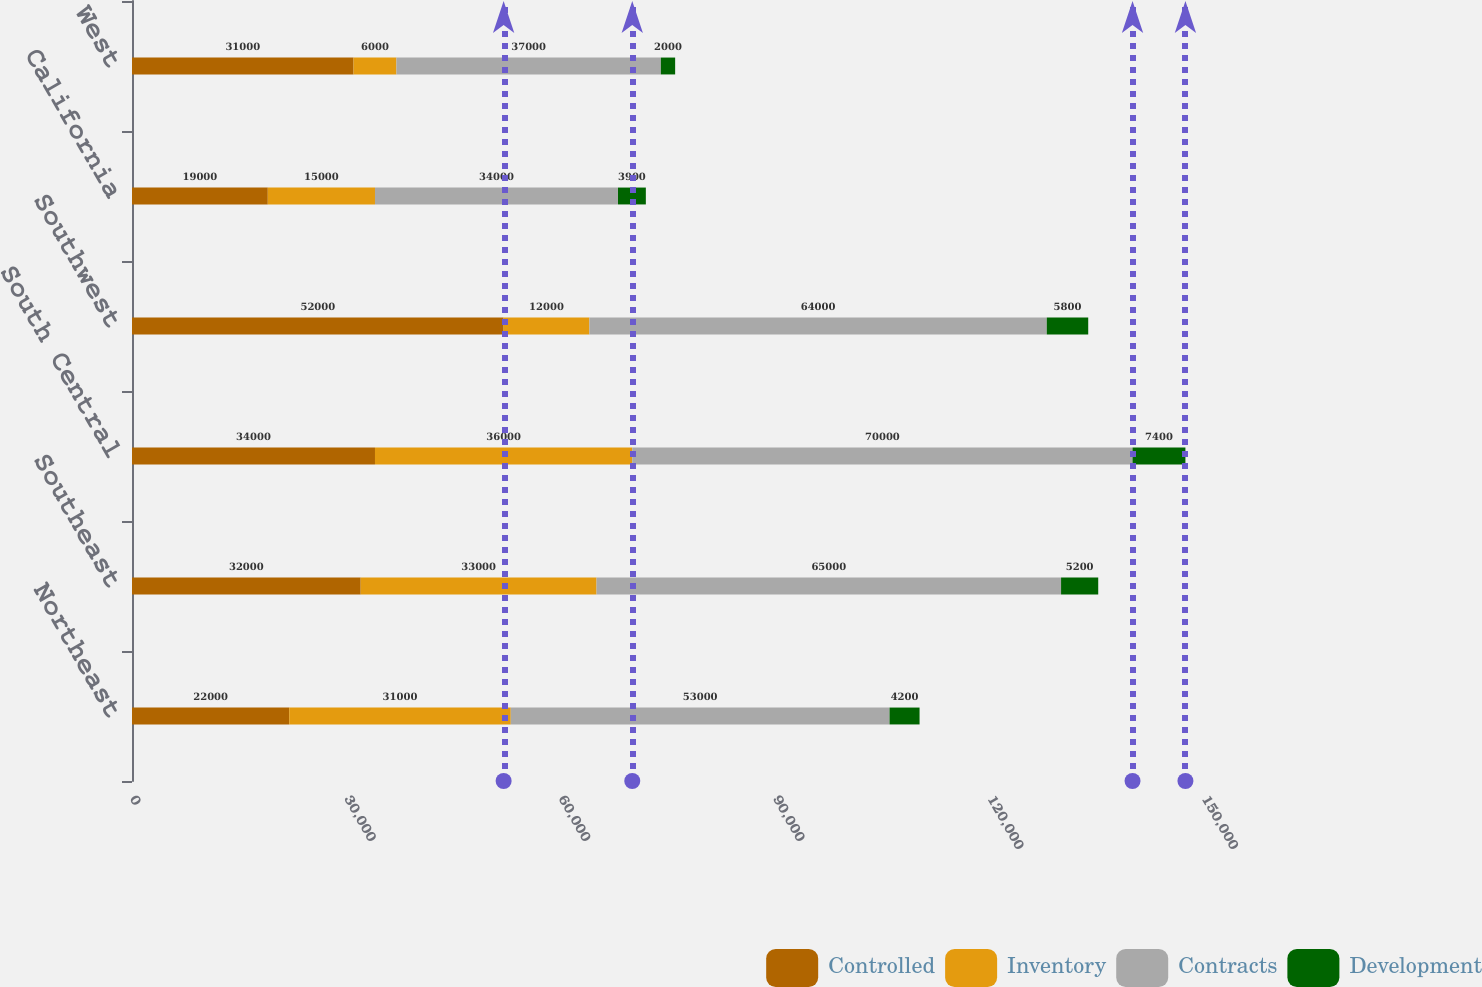<chart> <loc_0><loc_0><loc_500><loc_500><stacked_bar_chart><ecel><fcel>Northeast<fcel>Southeast<fcel>South Central<fcel>Southwest<fcel>California<fcel>West<nl><fcel>Controlled<fcel>22000<fcel>32000<fcel>34000<fcel>52000<fcel>19000<fcel>31000<nl><fcel>Inventory<fcel>31000<fcel>33000<fcel>36000<fcel>12000<fcel>15000<fcel>6000<nl><fcel>Contracts<fcel>53000<fcel>65000<fcel>70000<fcel>64000<fcel>34000<fcel>37000<nl><fcel>Development<fcel>4200<fcel>5200<fcel>7400<fcel>5800<fcel>3900<fcel>2000<nl></chart> 